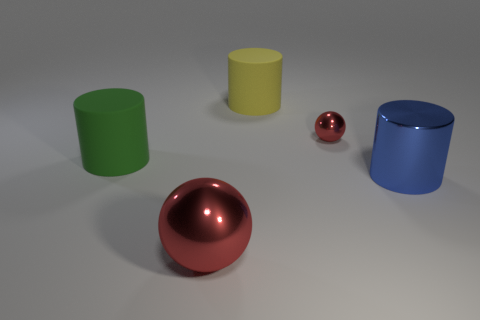Subtract all metallic cylinders. How many cylinders are left? 2 Add 5 big yellow matte cylinders. How many objects exist? 10 Subtract all green cylinders. How many cylinders are left? 2 Subtract 2 spheres. How many spheres are left? 0 Subtract all big blue metallic cylinders. Subtract all yellow cylinders. How many objects are left? 3 Add 5 shiny spheres. How many shiny spheres are left? 7 Add 2 small cyan rubber objects. How many small cyan rubber objects exist? 2 Subtract 0 brown spheres. How many objects are left? 5 Subtract all spheres. How many objects are left? 3 Subtract all gray balls. Subtract all cyan cubes. How many balls are left? 2 